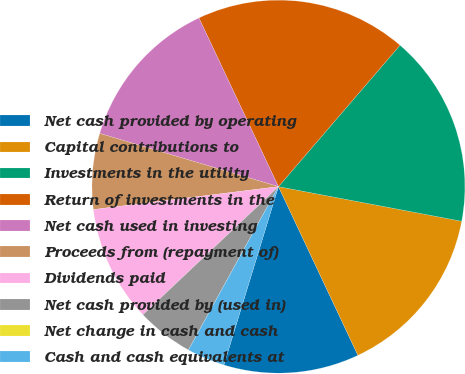Convert chart. <chart><loc_0><loc_0><loc_500><loc_500><pie_chart><fcel>Net cash provided by operating<fcel>Capital contributions to<fcel>Investments in the utility<fcel>Return of investments in the<fcel>Net cash used in investing<fcel>Proceeds from (repayment of)<fcel>Dividends paid<fcel>Net cash provided by (used in)<fcel>Net change in cash and cash<fcel>Cash and cash equivalents at<nl><fcel>11.73%<fcel>15.02%<fcel>16.67%<fcel>18.31%<fcel>13.38%<fcel>6.57%<fcel>10.09%<fcel>4.93%<fcel>0.0%<fcel>3.29%<nl></chart> 